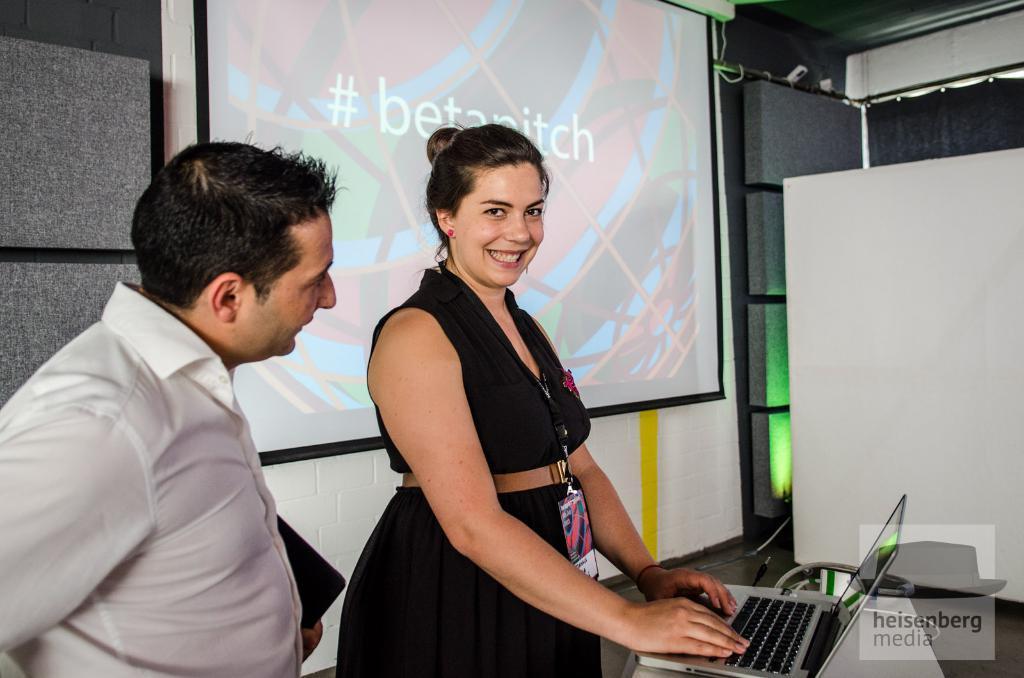How would you summarize this image in a sentence or two? This picture describe about a women wearing black color top with id card working on the silver laptop, smiling and giving a pose into the camera. Beside there is a man wearing a white shirt looking to the woman. Behind we can see the projector screen, curtain and wall. 